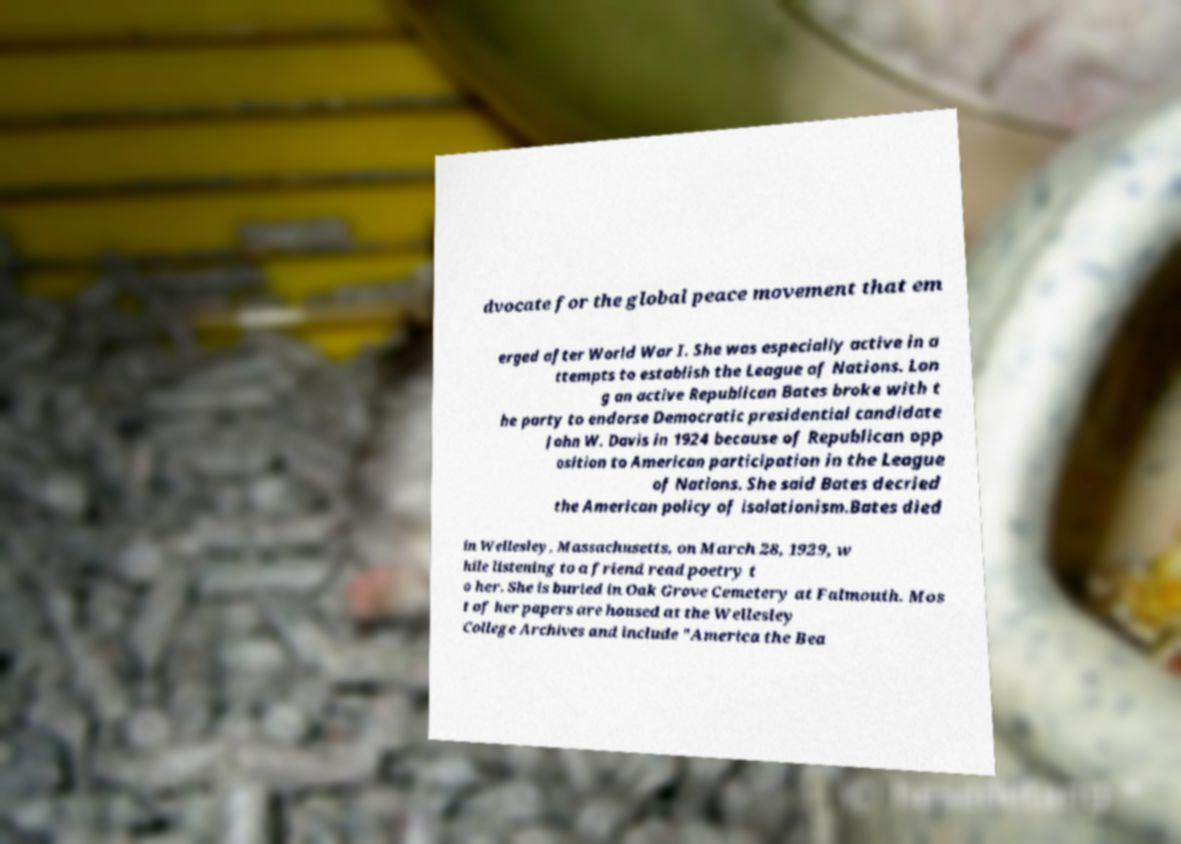Could you extract and type out the text from this image? dvocate for the global peace movement that em erged after World War I. She was especially active in a ttempts to establish the League of Nations. Lon g an active Republican Bates broke with t he party to endorse Democratic presidential candidate John W. Davis in 1924 because of Republican opp osition to American participation in the League of Nations. She said Bates decried the American policy of isolationism.Bates died in Wellesley, Massachusetts, on March 28, 1929, w hile listening to a friend read poetry t o her. She is buried in Oak Grove Cemetery at Falmouth. Mos t of her papers are housed at the Wellesley College Archives and include "America the Bea 